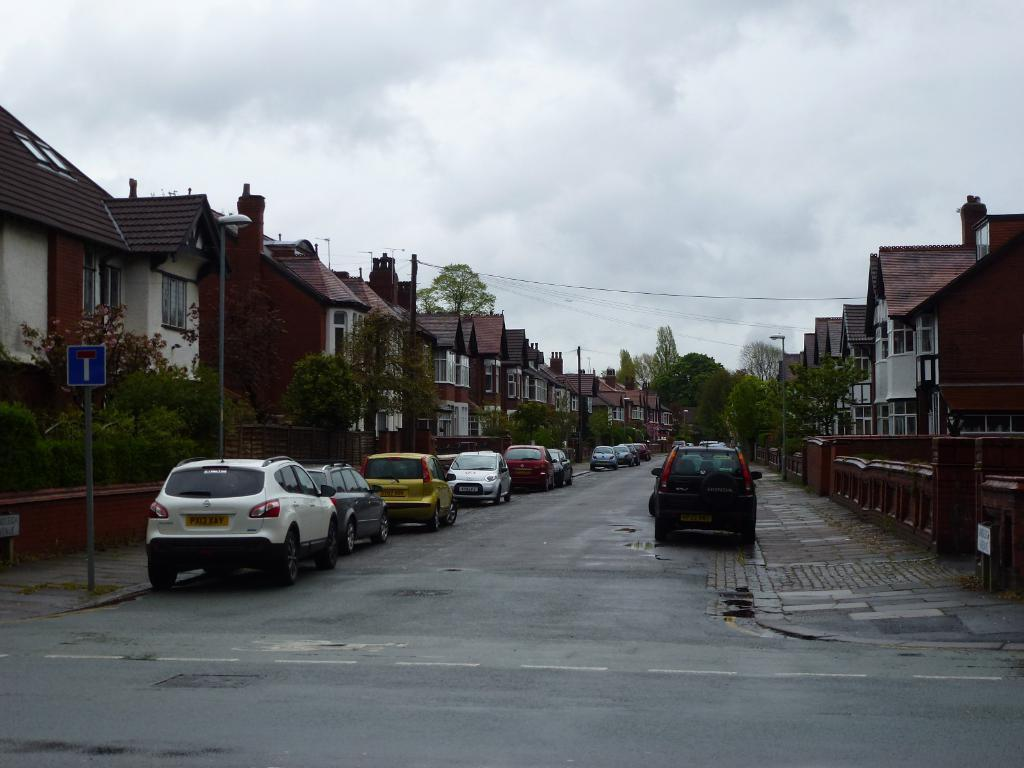What type of view is shown in the image? The image is a street view. What can be seen on the road in the image? There are cars parked on the road in the image. What is present on either side of the road? There are sign boards and trees on either side of the road, as well as buildings. Can you see any badges on the cars in the image? There is no mention of badges on the cars in the image, so we cannot determine if any are present. Is there a harbor visible in the image? There is no harbor present in the image; it is a street view with cars, sign boards, trees, and buildings. 